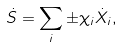Convert formula to latex. <formula><loc_0><loc_0><loc_500><loc_500>\dot { S } = \sum _ { i } \pm \chi _ { i } \dot { X } _ { i } ,</formula> 